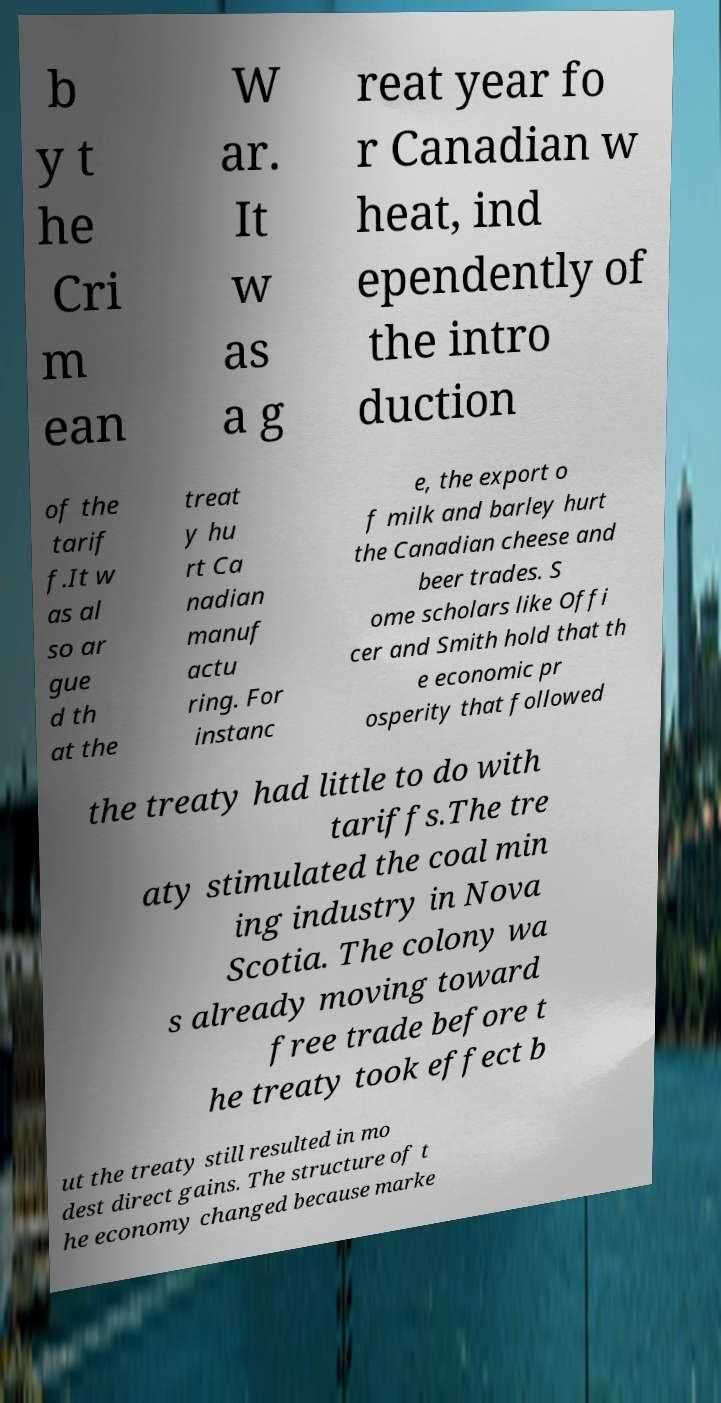Please read and relay the text visible in this image. What does it say? b y t he Cri m ean W ar. It w as a g reat year fo r Canadian w heat, ind ependently of the intro duction of the tarif f.It w as al so ar gue d th at the treat y hu rt Ca nadian manuf actu ring. For instanc e, the export o f milk and barley hurt the Canadian cheese and beer trades. S ome scholars like Offi cer and Smith hold that th e economic pr osperity that followed the treaty had little to do with tariffs.The tre aty stimulated the coal min ing industry in Nova Scotia. The colony wa s already moving toward free trade before t he treaty took effect b ut the treaty still resulted in mo dest direct gains. The structure of t he economy changed because marke 